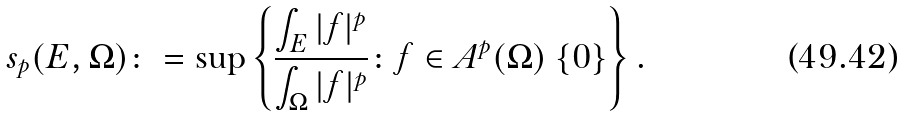<formula> <loc_0><loc_0><loc_500><loc_500>s _ { p } ( E , \Omega ) \colon = \sup \left \{ \frac { \int _ { E } | f | ^ { p } } { \int _ { \Omega } | f | ^ { p } } \colon f \in A ^ { p } ( \Omega ) \ \{ 0 \} \right \} .</formula> 